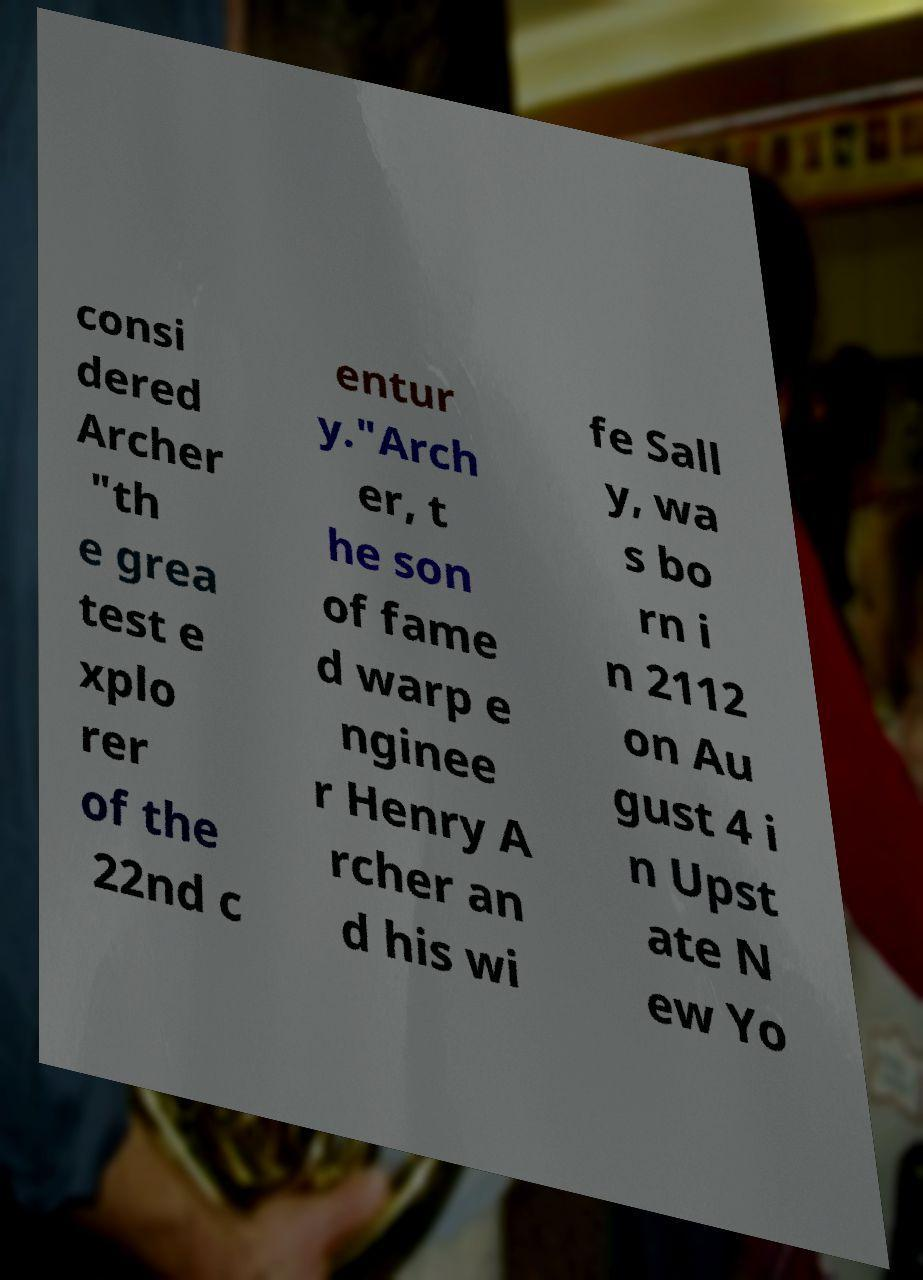Could you assist in decoding the text presented in this image and type it out clearly? consi dered Archer "th e grea test e xplo rer of the 22nd c entur y."Arch er, t he son of fame d warp e nginee r Henry A rcher an d his wi fe Sall y, wa s bo rn i n 2112 on Au gust 4 i n Upst ate N ew Yo 